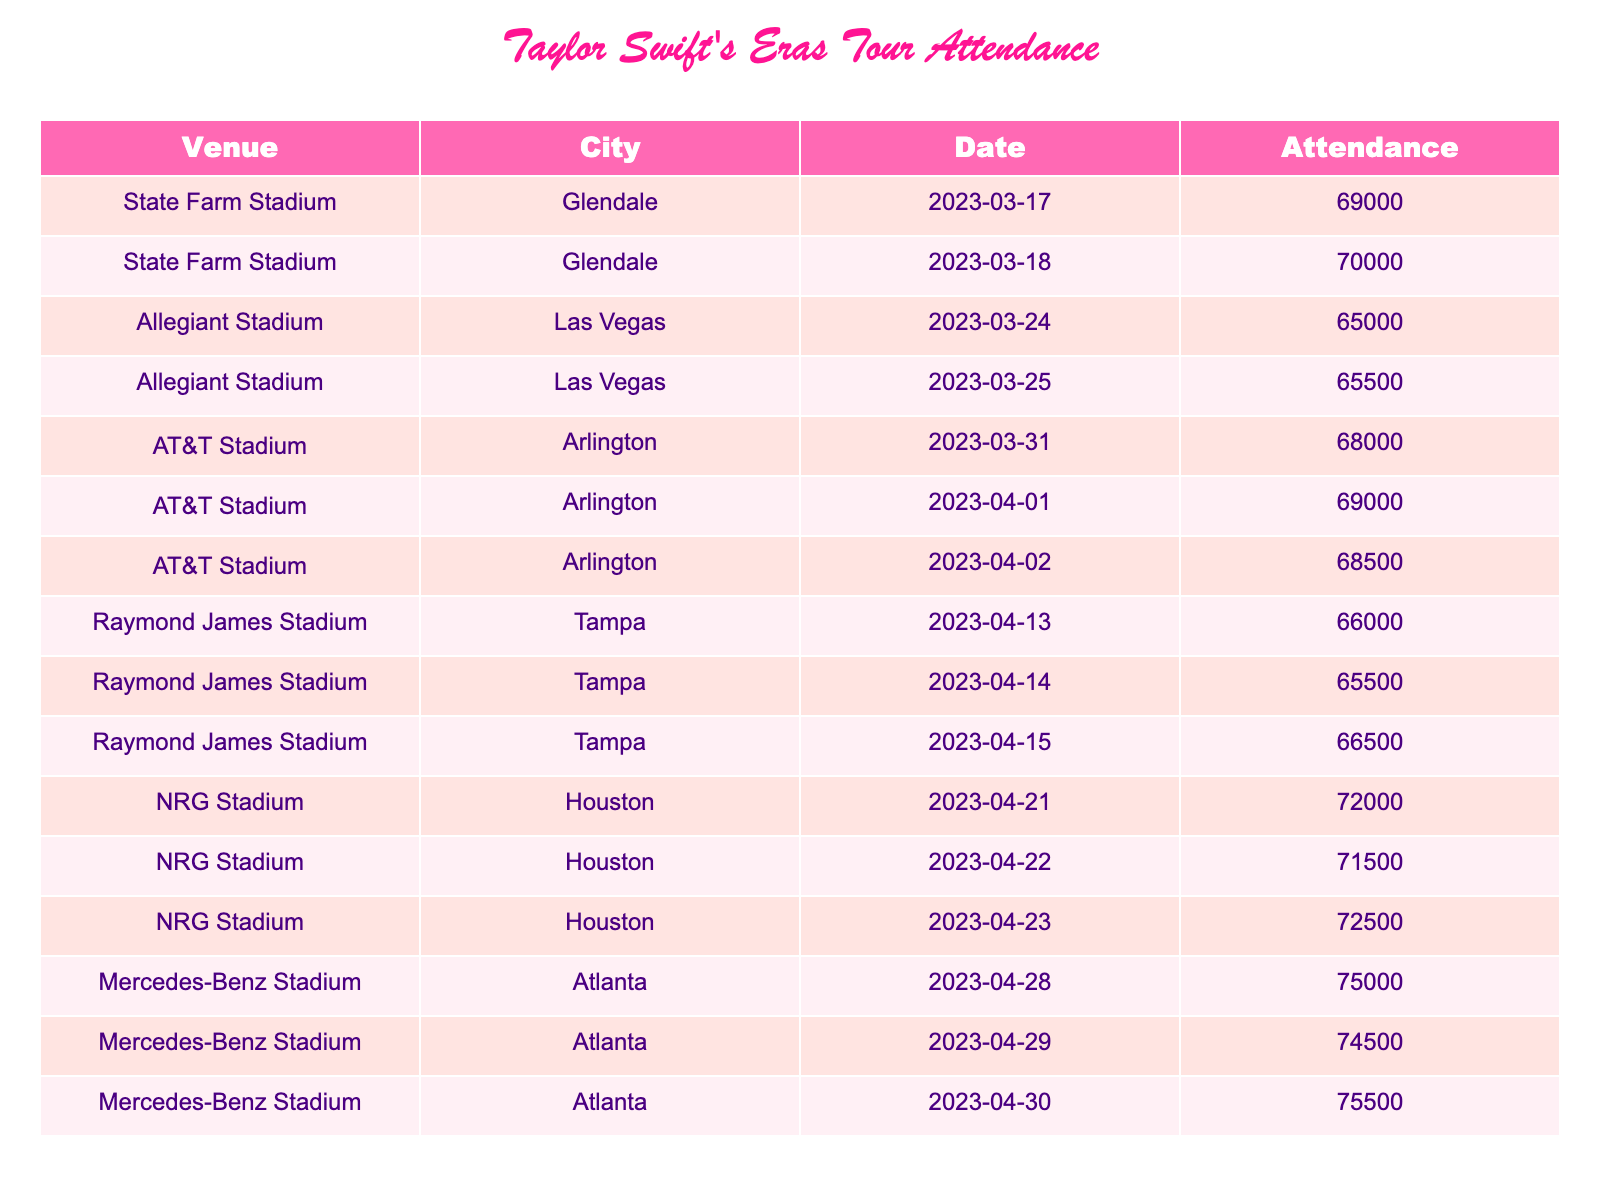What is the highest attendance recorded during the Eras Tour? By examining the attendance figures listed in the table, we can see that the highest number is 75,500, which occurred at Mercedes-Benz Stadium in Atlanta on April 30, 2023.
Answer: 75,500 What was the total attendance at Allegiant Stadium in Las Vegas across both concert dates? To find the total attendance at Allegiant Stadium, we add the attendance for both dates: 65,000 + 65,500 = 130,500.
Answer: 130,500 Is the attendance for the concert in Tampa greater than 66,000 on any of the days? Looking at the attendance figures for Raymond James Stadium in Tampa, we see the attendances are 66,000, 65,500, and 65,800. Since one day shows exactly 66,000, the answer is yes.
Answer: Yes What is the average attendance for the three nights at NRG Stadium in Houston? To calculate the average attendance, first add the attendances: 72,000 + 71,500 + 72,500 = 216,000. Then, divide by the number of concerts, which is 3. Thus, the average attendance is 216,000 / 3 = 72,000.
Answer: 72,000 Was there ever a concert during the Eras Tour with an attendance of less than 65,000? By checking the attendance numbers, all listed figures are 65,000 or higher, making the answer no.
Answer: No What city had the second highest total attendance if we sum all concerts in each city? First, we calculate the total attendance per city: Glendale = 69,000 + 70,000 = 139,000; Las Vegas = 65,000 + 65,500 = 130,500; Arlington = 68,000 + 69,000 + 68,500 = 205,500; Tampa = 66,000 + 65,500 + 66,500 = 198,000; Houston = 72,000 + 71,500 + 72,500 = 216,000; Atlanta = 75,000 + 74,500 + 75,500 = 225,000. The city with the second highest total attendance is Arlington with 205,500.
Answer: Arlington What was the difference in attendance between the last concert in Atlanta and the last concert in Houston? The last concert in Atlanta had an attendance of 75,500, while the last concert in Houston had an attendance of 72,500. The difference is thus 75,500 - 72,500 = 3,000.
Answer: 3,000 How many more people attended the concert in Glendale compared to the concert in Tampa on their respective highest days? The highest attendance in Glendale is 70,000, and in Tampa, it is 66,000. The difference is 70,000 - 66,000 = 4,000.
Answer: 4,000 